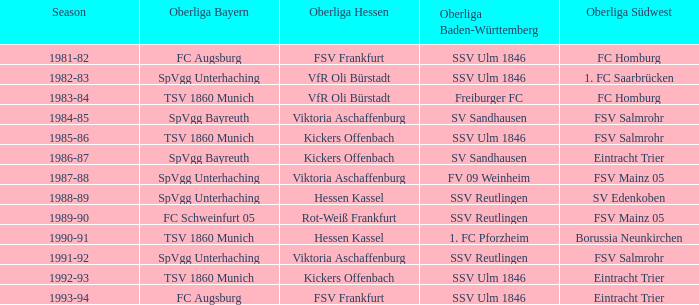Help me parse the entirety of this table. {'header': ['Season', 'Oberliga Bayern', 'Oberliga Hessen', 'Oberliga Baden-Württemberg', 'Oberliga Südwest'], 'rows': [['1981-82', 'FC Augsburg', 'FSV Frankfurt', 'SSV Ulm 1846', 'FC Homburg'], ['1982-83', 'SpVgg Unterhaching', 'VfR Oli Bürstadt', 'SSV Ulm 1846', '1. FC Saarbrücken'], ['1983-84', 'TSV 1860 Munich', 'VfR Oli Bürstadt', 'Freiburger FC', 'FC Homburg'], ['1984-85', 'SpVgg Bayreuth', 'Viktoria Aschaffenburg', 'SV Sandhausen', 'FSV Salmrohr'], ['1985-86', 'TSV 1860 Munich', 'Kickers Offenbach', 'SSV Ulm 1846', 'FSV Salmrohr'], ['1986-87', 'SpVgg Bayreuth', 'Kickers Offenbach', 'SV Sandhausen', 'Eintracht Trier'], ['1987-88', 'SpVgg Unterhaching', 'Viktoria Aschaffenburg', 'FV 09 Weinheim', 'FSV Mainz 05'], ['1988-89', 'SpVgg Unterhaching', 'Hessen Kassel', 'SSV Reutlingen', 'SV Edenkoben'], ['1989-90', 'FC Schweinfurt 05', 'Rot-Weiß Frankfurt', 'SSV Reutlingen', 'FSV Mainz 05'], ['1990-91', 'TSV 1860 Munich', 'Hessen Kassel', '1. FC Pforzheim', 'Borussia Neunkirchen'], ['1991-92', 'SpVgg Unterhaching', 'Viktoria Aschaffenburg', 'SSV Reutlingen', 'FSV Salmrohr'], ['1992-93', 'TSV 1860 Munich', 'Kickers Offenbach', 'SSV Ulm 1846', 'Eintracht Trier'], ['1993-94', 'FC Augsburg', 'FSV Frankfurt', 'SSV Ulm 1846', 'Eintracht Trier']]} Which Oberliga Bayern has a Season of 1981-82? FC Augsburg. 